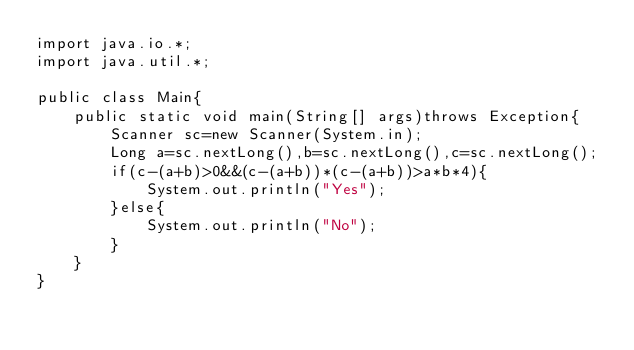<code> <loc_0><loc_0><loc_500><loc_500><_Java_>import java.io.*;
import java.util.*;

public class Main{
    public static void main(String[] args)throws Exception{
        Scanner sc=new Scanner(System.in);
        Long a=sc.nextLong(),b=sc.nextLong(),c=sc.nextLong();
        if(c-(a+b)>0&&(c-(a+b))*(c-(a+b))>a*b*4){
            System.out.println("Yes");
        }else{
            System.out.println("No");
        }
    }
}</code> 